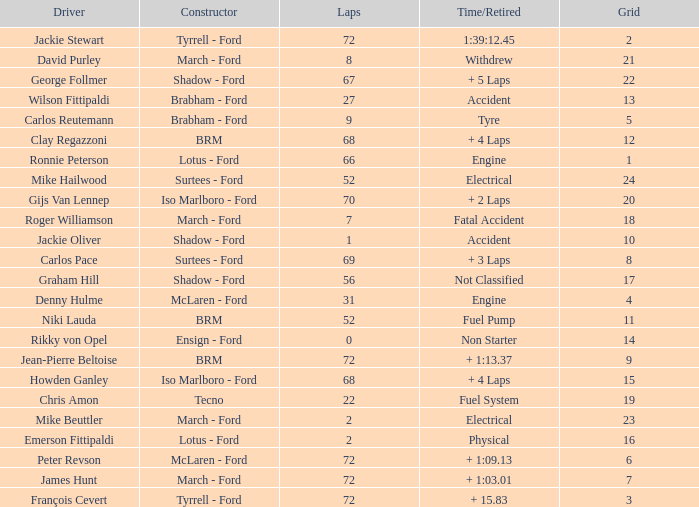What is the top grid that laps less than 66 and a retried engine? 4.0. 